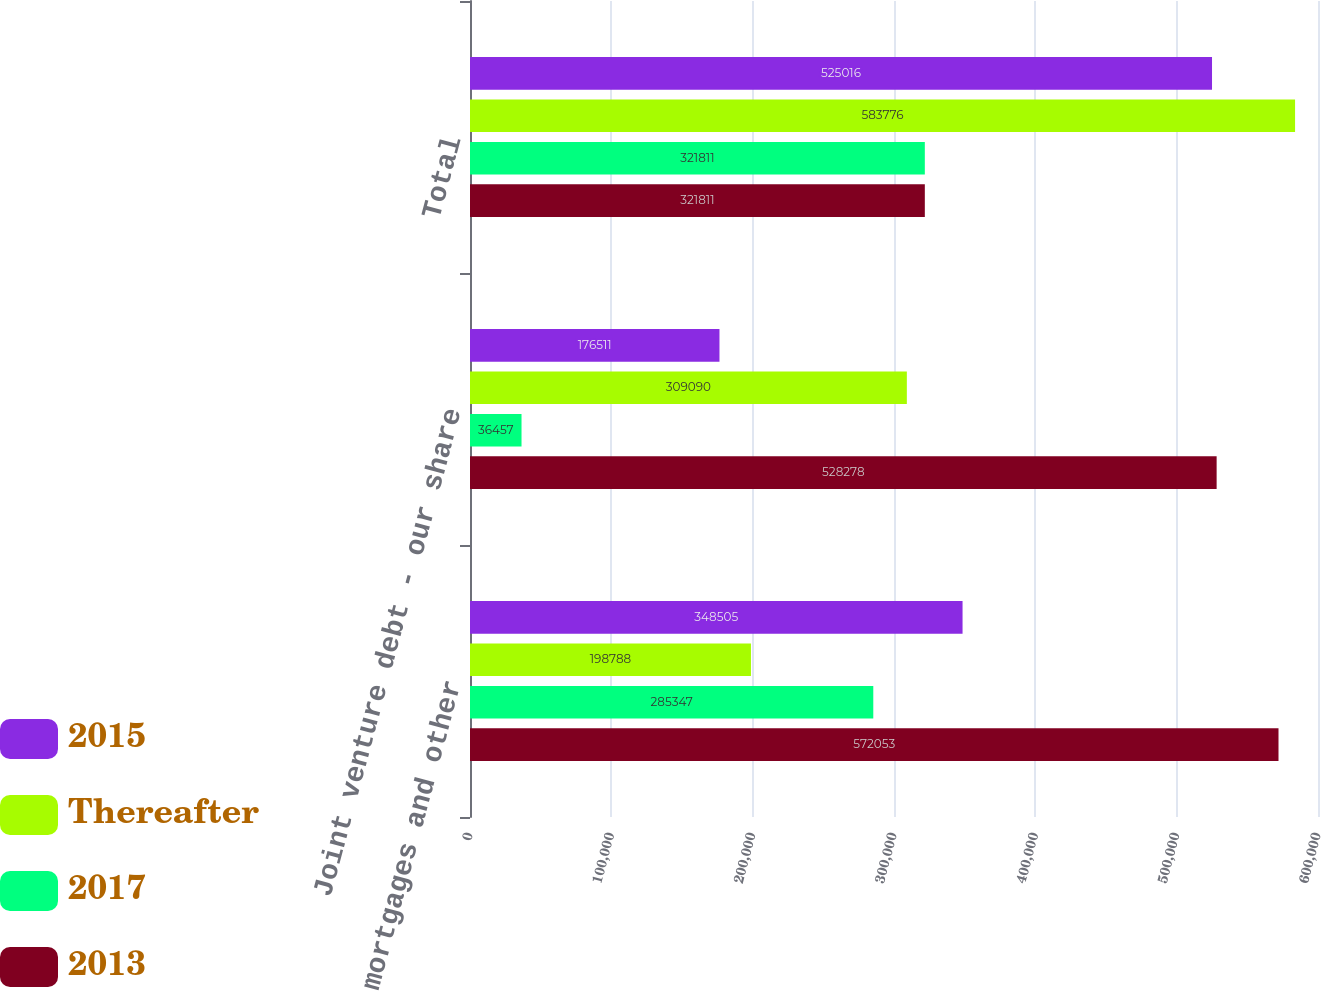Convert chart to OTSL. <chart><loc_0><loc_0><loc_500><loc_500><stacked_bar_chart><ecel><fcel>Property mortgages and other<fcel>Joint venture debt - our share<fcel>Total<nl><fcel>2015<fcel>348505<fcel>176511<fcel>525016<nl><fcel>Thereafter<fcel>198788<fcel>309090<fcel>583776<nl><fcel>2017<fcel>285347<fcel>36457<fcel>321811<nl><fcel>2013<fcel>572053<fcel>528278<fcel>321811<nl></chart> 